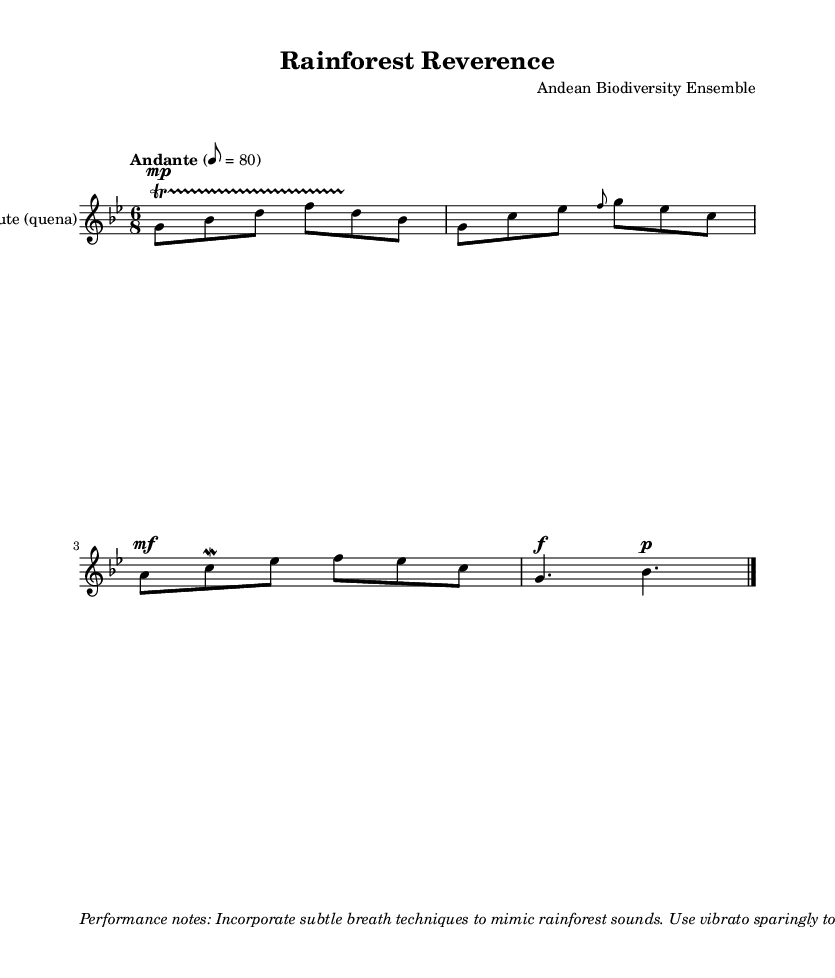What is the key signature of this music? The key signature indicated in the sheet music is G minor, which corresponds to two flats (B flat and E flat). It is displayed at the beginning of the staff lines and defines the notes used in the piece.
Answer: G minor What is the time signature of this music? The time signature is 6/8, represented by the two numbers at the beginning of the measure. This means there are six eighth notes in each measure, providing a compound duple feel to the music.
Answer: 6/8 What is the tempo indicated in the sheet music? The tempo marking "Andante" suggests a moderate pace, typically around 76-108 beats per minute. It provides guidance on the speed at which the piece should be performed. The exact marking given states "8 = 80" which means each eighth note is played at a speed of 80 BPM.
Answer: 80 What instrument is specified for this score? The instrument specified in the score is an "Andean flute (quena)," as listed in the staff name. This indicates the specific type of flute and its cultural significance in Andean music.
Answer: Andean flute (quena) How should performers mimic rainforest sounds according to the performance notes? The performance notes instruct musicians to incorporate subtle breath techniques that mimic the sounds of the rainforest. This includes using specific techniques to emulate the diverse wildlife vocalizations found in the rainforest setting.
Answer: Subtle breath techniques What dynamic indication is used for the first phrase? The first phrase of the music contains a dynamic marking of "mp" (mezzo-piano), which indicates that this section should be played moderately soft. This dynamic is crucial for expressing the emotional quality of the melody.
Answer: mezzo-piano What ornament is applied to the third note of the melody? The ornament applied to the third note (E flat) in the melody is a "mordent." This is noted by the specific symbol that looks like a zigzag above the note, indicating a rapid alternation between the note and the note above it.
Answer: mordent 